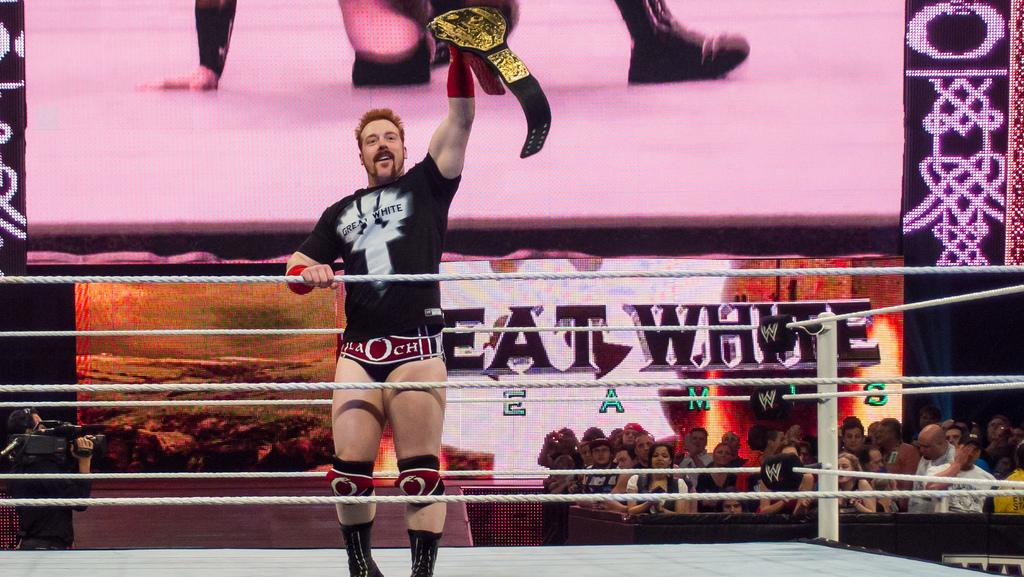<image>
Summarize the visual content of the image. A wrestler with the word "white" on his shirt holds up a trophy belt. 